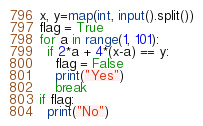<code> <loc_0><loc_0><loc_500><loc_500><_Python_>x, y=map(int, input().split())
flag = True
for a in range(1, 101):
  if 2*a + 4*(x-a) == y:
    flag = False
    print("Yes")
    break
if flag:
  print("No")</code> 